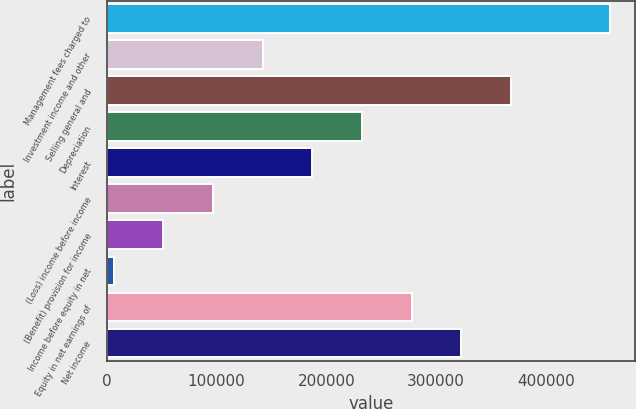Convert chart. <chart><loc_0><loc_0><loc_500><loc_500><bar_chart><fcel>Management fees charged to<fcel>Investment income and other<fcel>Selling general and<fcel>Depreciation<fcel>Interest<fcel>(Loss) income before income<fcel>(Benefit) provision for income<fcel>Income before equity in net<fcel>Equity in net earnings of<fcel>Net income<nl><fcel>458373<fcel>142107<fcel>368011<fcel>232468<fcel>187288<fcel>96925.8<fcel>51744.9<fcel>6564<fcel>277649<fcel>322830<nl></chart> 